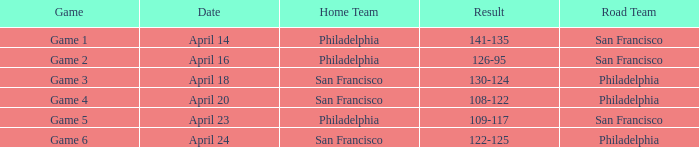What was the result of the game played on April 16 with Philadelphia as home team? 126-95. 